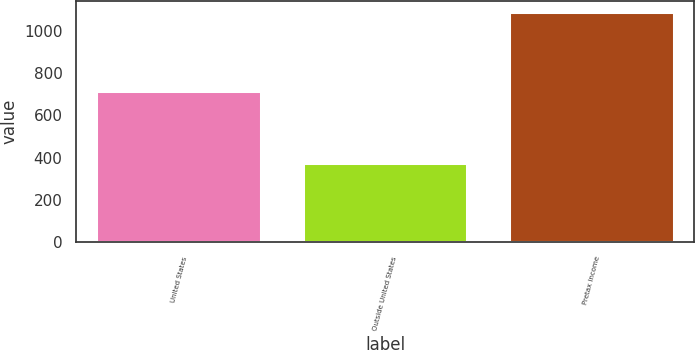Convert chart to OTSL. <chart><loc_0><loc_0><loc_500><loc_500><bar_chart><fcel>United States<fcel>Outside United States<fcel>Pretax income<nl><fcel>714<fcel>373<fcel>1087<nl></chart> 